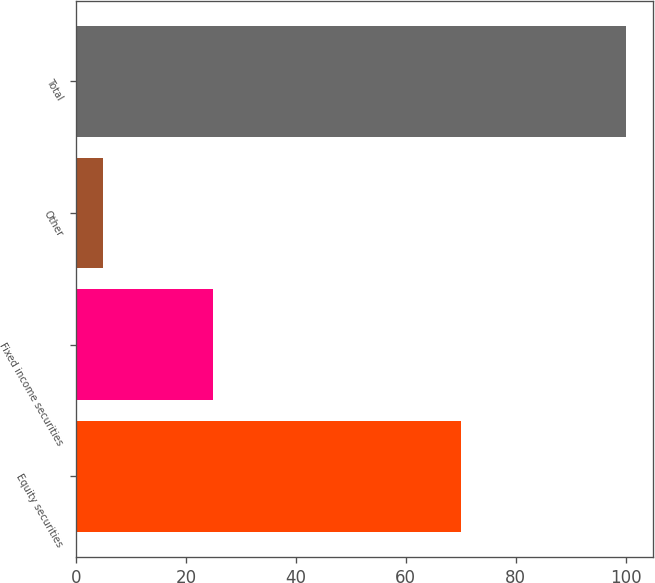Convert chart to OTSL. <chart><loc_0><loc_0><loc_500><loc_500><bar_chart><fcel>Equity securities<fcel>Fixed income securities<fcel>Other<fcel>Total<nl><fcel>70<fcel>25<fcel>5<fcel>100<nl></chart> 